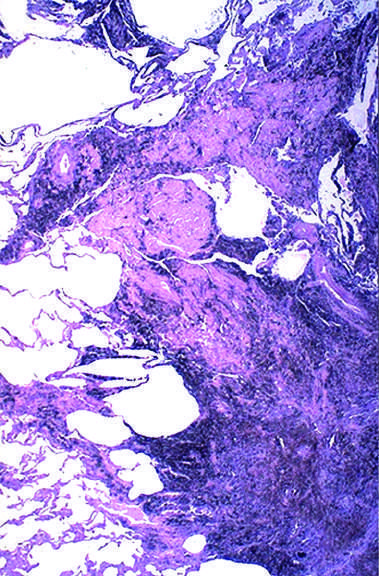s high-power view of another region associated with fibrosis?
Answer the question using a single word or phrase. No 